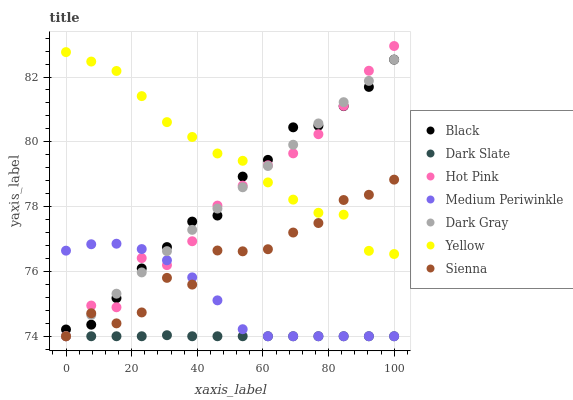Does Dark Slate have the minimum area under the curve?
Answer yes or no. Yes. Does Yellow have the maximum area under the curve?
Answer yes or no. Yes. Does Hot Pink have the minimum area under the curve?
Answer yes or no. No. Does Hot Pink have the maximum area under the curve?
Answer yes or no. No. Is Dark Gray the smoothest?
Answer yes or no. Yes. Is Sienna the roughest?
Answer yes or no. Yes. Is Hot Pink the smoothest?
Answer yes or no. No. Is Hot Pink the roughest?
Answer yes or no. No. Does Sienna have the lowest value?
Answer yes or no. Yes. Does Yellow have the lowest value?
Answer yes or no. No. Does Hot Pink have the highest value?
Answer yes or no. Yes. Does Medium Periwinkle have the highest value?
Answer yes or no. No. Is Medium Periwinkle less than Yellow?
Answer yes or no. Yes. Is Yellow greater than Medium Periwinkle?
Answer yes or no. Yes. Does Dark Gray intersect Dark Slate?
Answer yes or no. Yes. Is Dark Gray less than Dark Slate?
Answer yes or no. No. Is Dark Gray greater than Dark Slate?
Answer yes or no. No. Does Medium Periwinkle intersect Yellow?
Answer yes or no. No. 